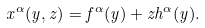Convert formula to latex. <formula><loc_0><loc_0><loc_500><loc_500>x ^ { \alpha } ( y , z ) = f ^ { \alpha } ( y ) + z h ^ { \alpha } ( y ) .</formula> 